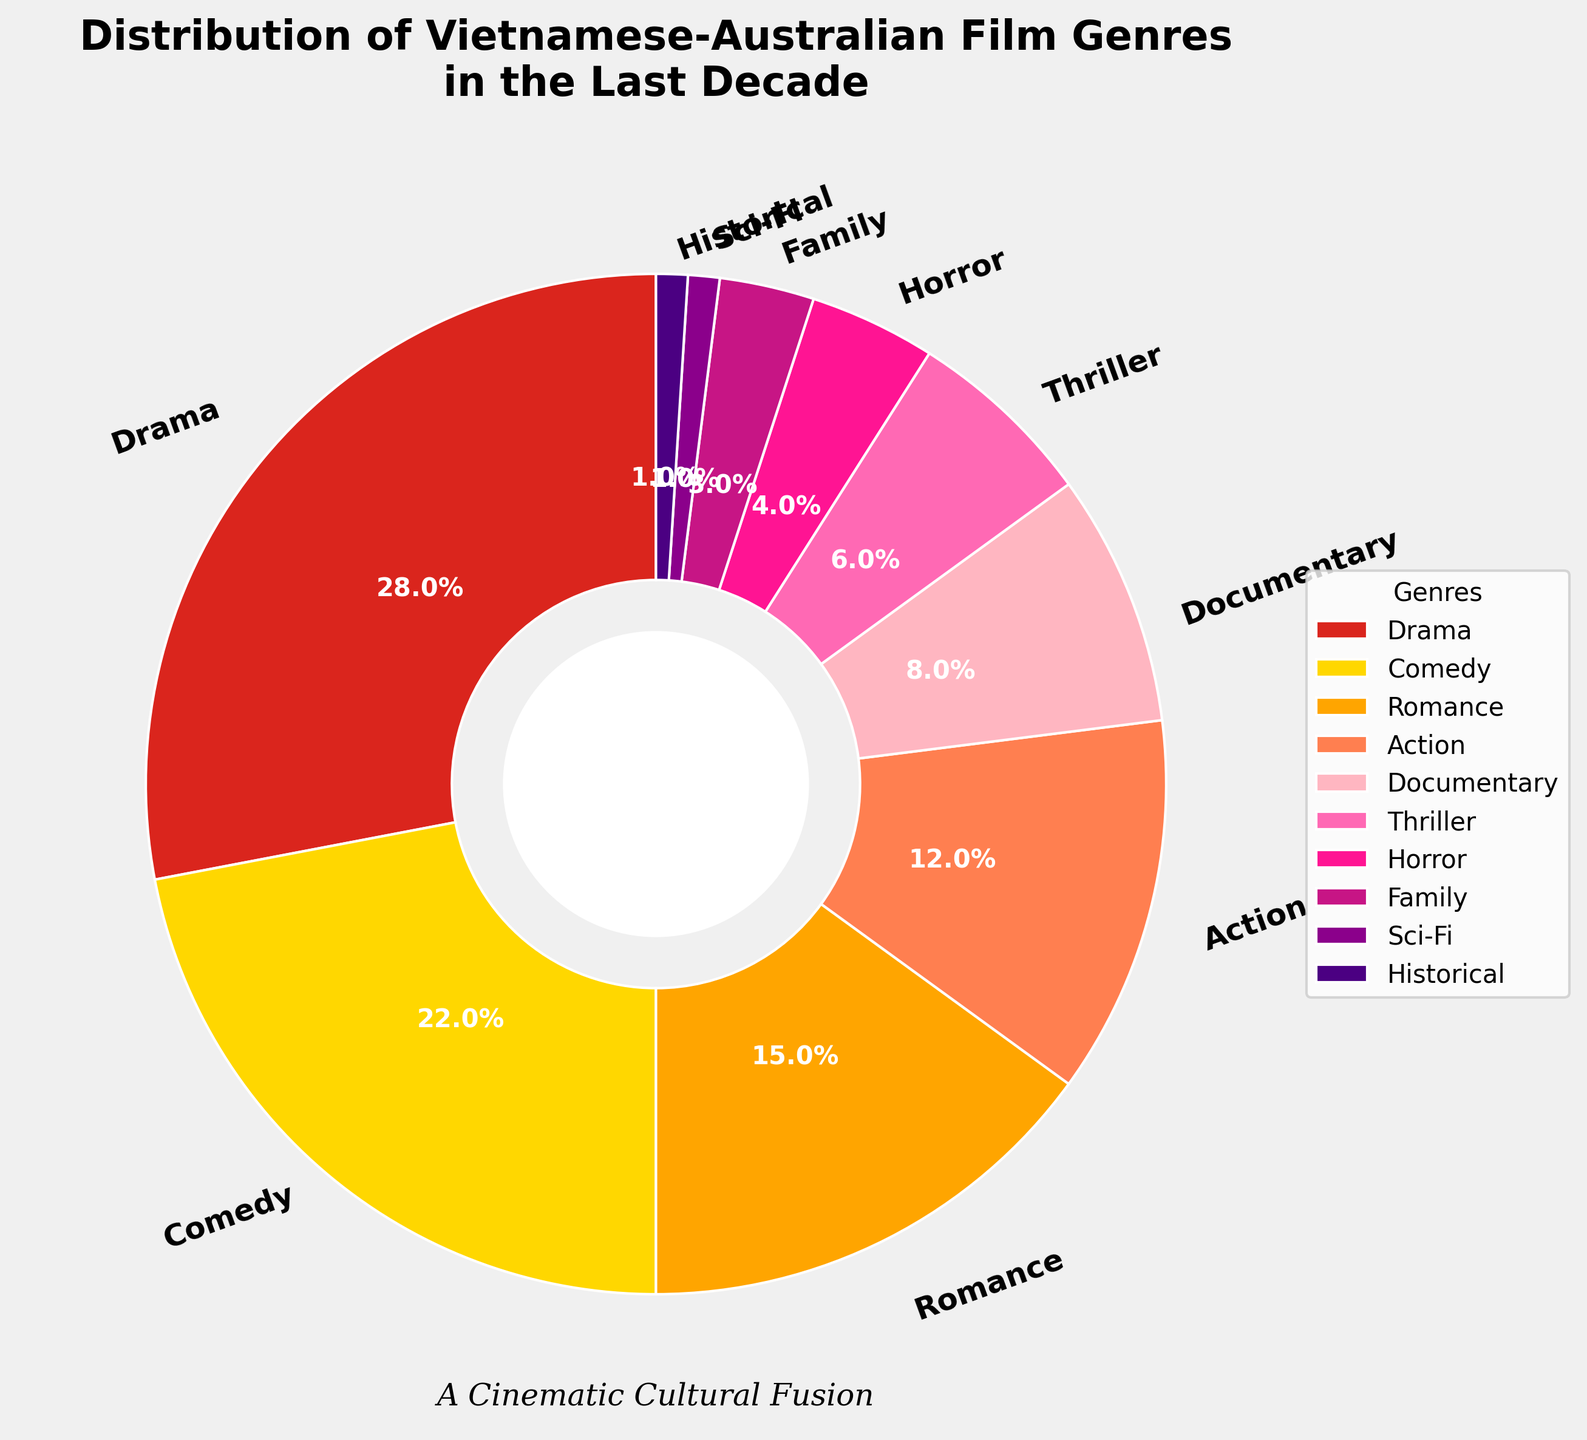What genre has the largest percentage? The largest percentage on the pie chart is 28%, which corresponds to Drama.
Answer: Drama Which genre has a higher percentage: Comedy or Action? Comedy has a percentage of 22% while Action has 12%. Since 22% is greater than 12%, Comedy has a higher percentage.
Answer: Comedy What is the total percentage for Thriller, Horror, Family, and Sci-Fi combined? To find the total percentage for Thriller, Horror, Family, and Sci-Fi, we need to sum their respective percentages: 6% (Thriller) + 4% (Horror) + 3% (Family) + 1% (Sci-Fi) = 14%.
Answer: 14% How many more percentage points is Drama compared to Documentary? Drama has 28% while Documentary has 8%. To find the difference, subtract 8 from 28: 28% - 8% = 20%.
Answer: 20% Which genre has the smallest percentage? Observing the percentages, both Sci-Fi and Historical have the smallest figure at 1%.
Answer: Sci-Fi and Historical Are there more films in the Action genre or the Romance genre? The Action genre has 12%, while Romance has 15%. Since 15% is greater than 12%, there are more films in the Romance genre.
Answer: Romance What two genres combined make up exactly 30% of the total? To find two genres that sum up to 30%, we can look at the genres Action (12%) and Thriller (6%). When combined with Horror (4%) and Family (3%) then Sci-Fi (1%) gives 30%.
Answer: Action, Thriller, Horror, Family, and Sci-Fi How does the percentage of Documentary films compare to Family and Historical films combined? Documentary has 8%, while Family has 3% and Historical has 1%. Combined, Family and Historical total to 3% + 1% = 4%. Since 8% is greater than 4%, there are more Documentary films.
Answer: Documentary What are the three most prevalent genres? By looking at the percentages, the three genres with the highest values are Drama (28%), Comedy (22%), and Romance (15%).
Answer: Drama, Comedy, and Romance What is the total percentage of genres that constitute less than 10% each? The genres with less than 10% are Documentary (8%), Thriller (6%), Horror (4%), Family (3%), Sci-Fi (1%), and Historical (1%). Adding them up: 8% + 6% + 4% + 3% + 1% + 1% = 23%.
Answer: 23% 